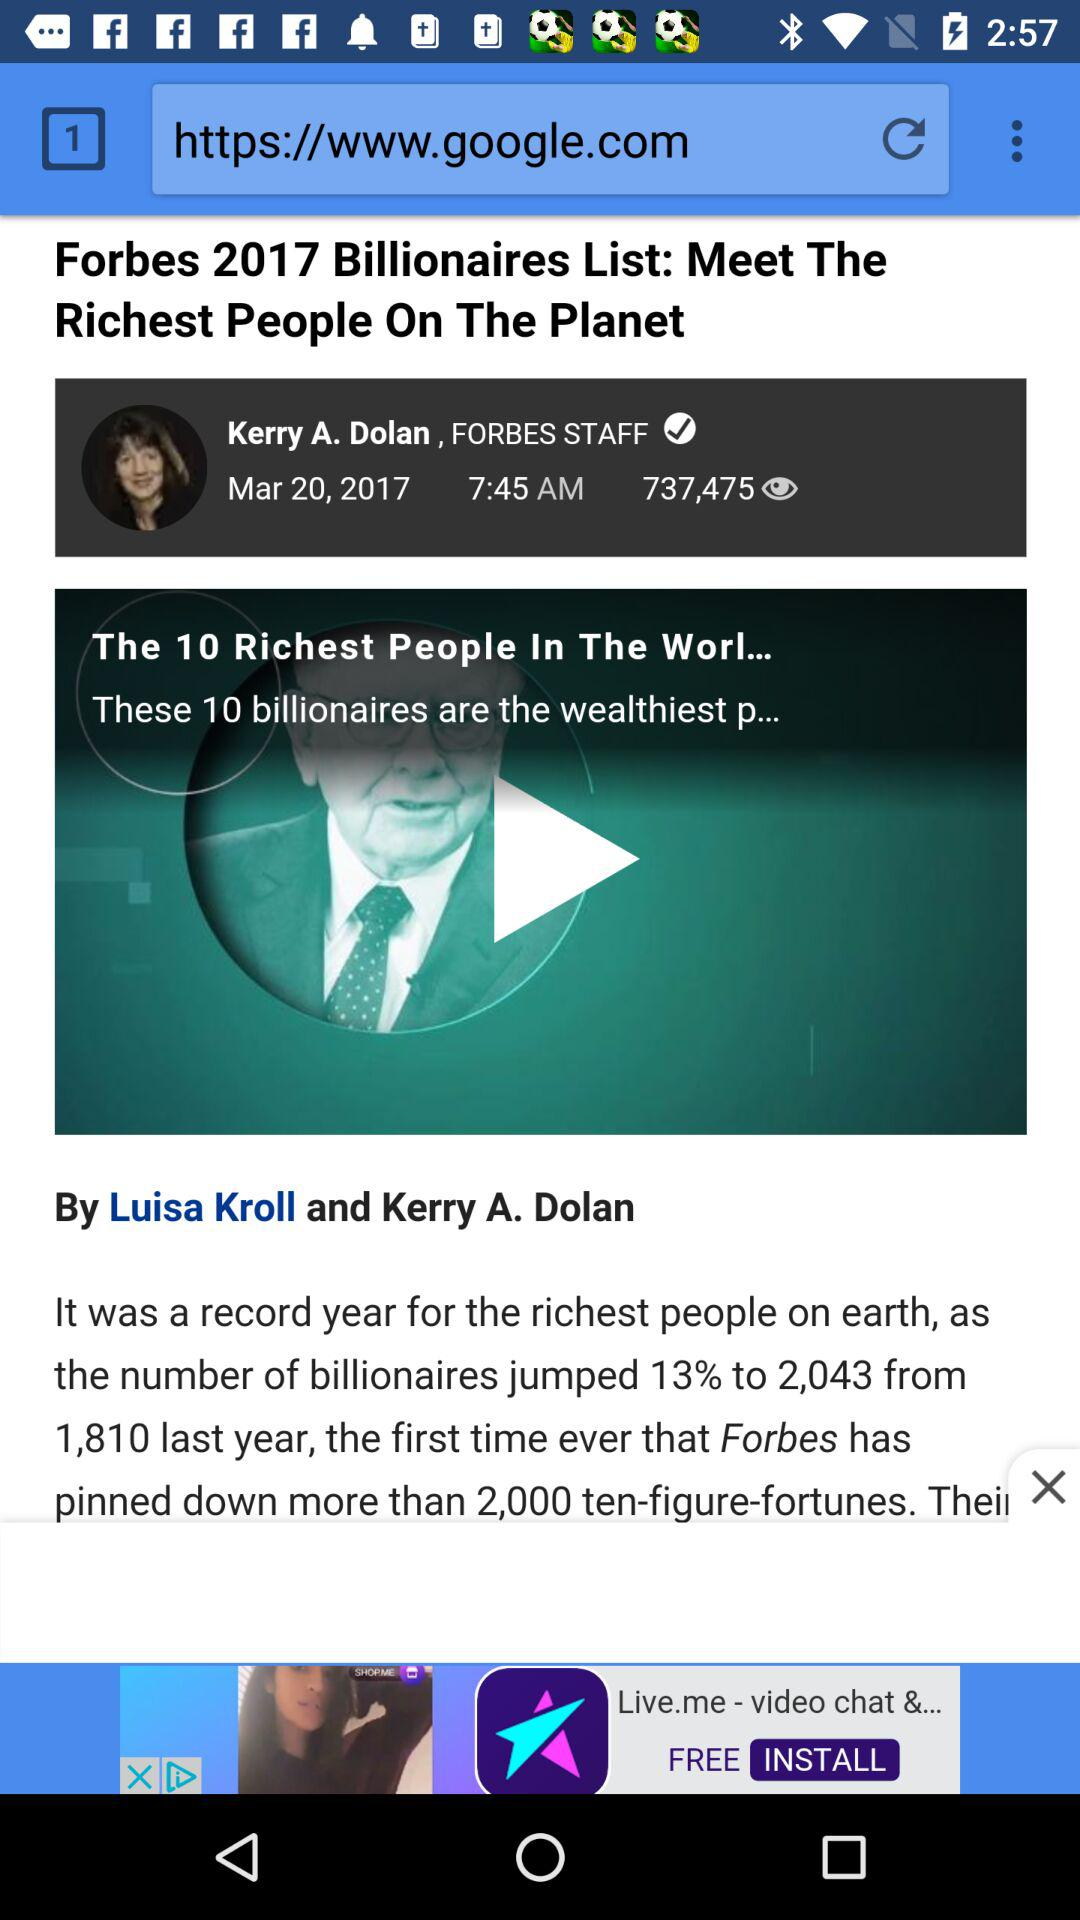How much has the percentage of billionaires increased since last year? The percentage has increased by 13. 